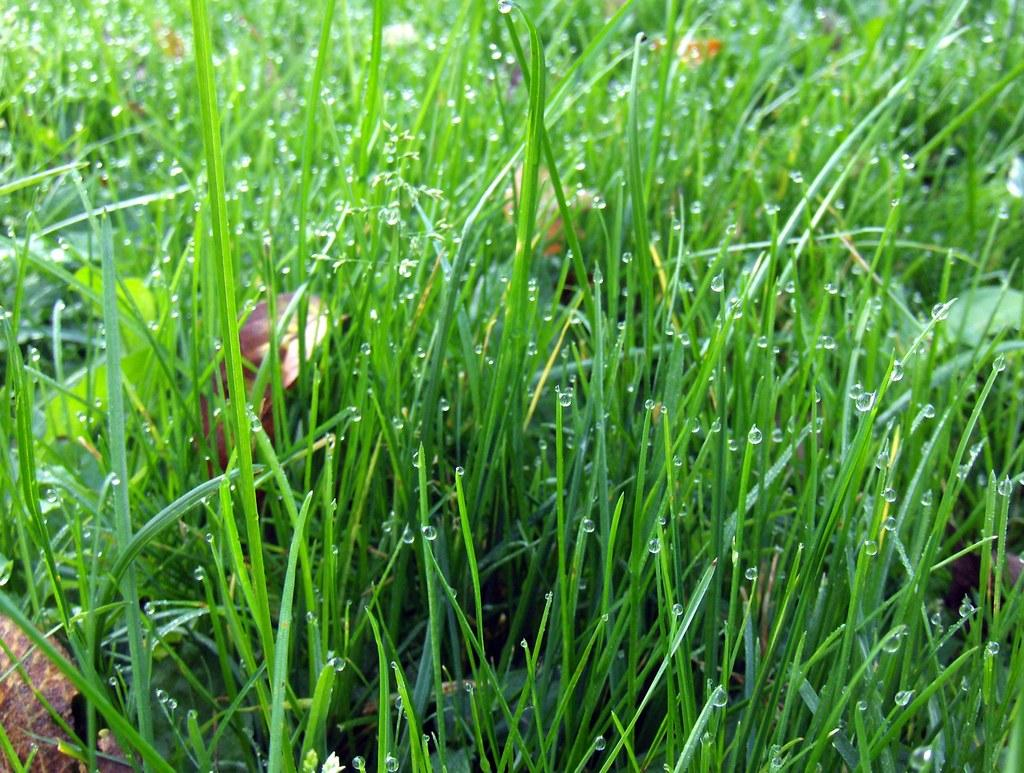What type of vegetation is present on the ground in the image? There is grass on the ground in the image. What else can be seen in the image besides the grass? There are water drops visible in the image. What arithmetic problem is being solved in the image? There is no arithmetic problem present in the image. What is the level of disgust that can be observed in the image? There is no indication of disgust in the image, as it only features grass and water drops. 